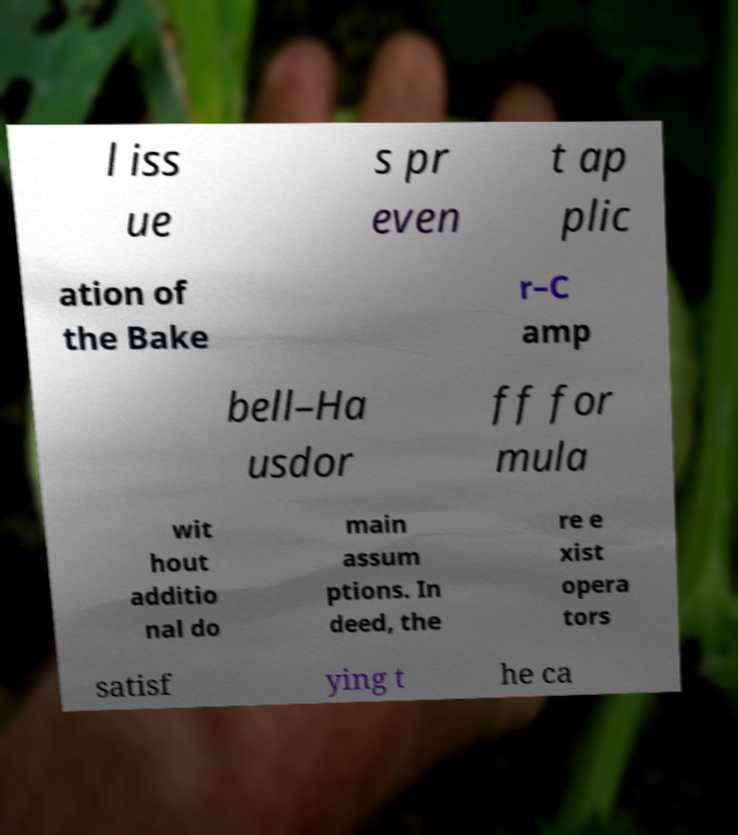There's text embedded in this image that I need extracted. Can you transcribe it verbatim? l iss ue s pr even t ap plic ation of the Bake r–C amp bell–Ha usdor ff for mula wit hout additio nal do main assum ptions. In deed, the re e xist opera tors satisf ying t he ca 